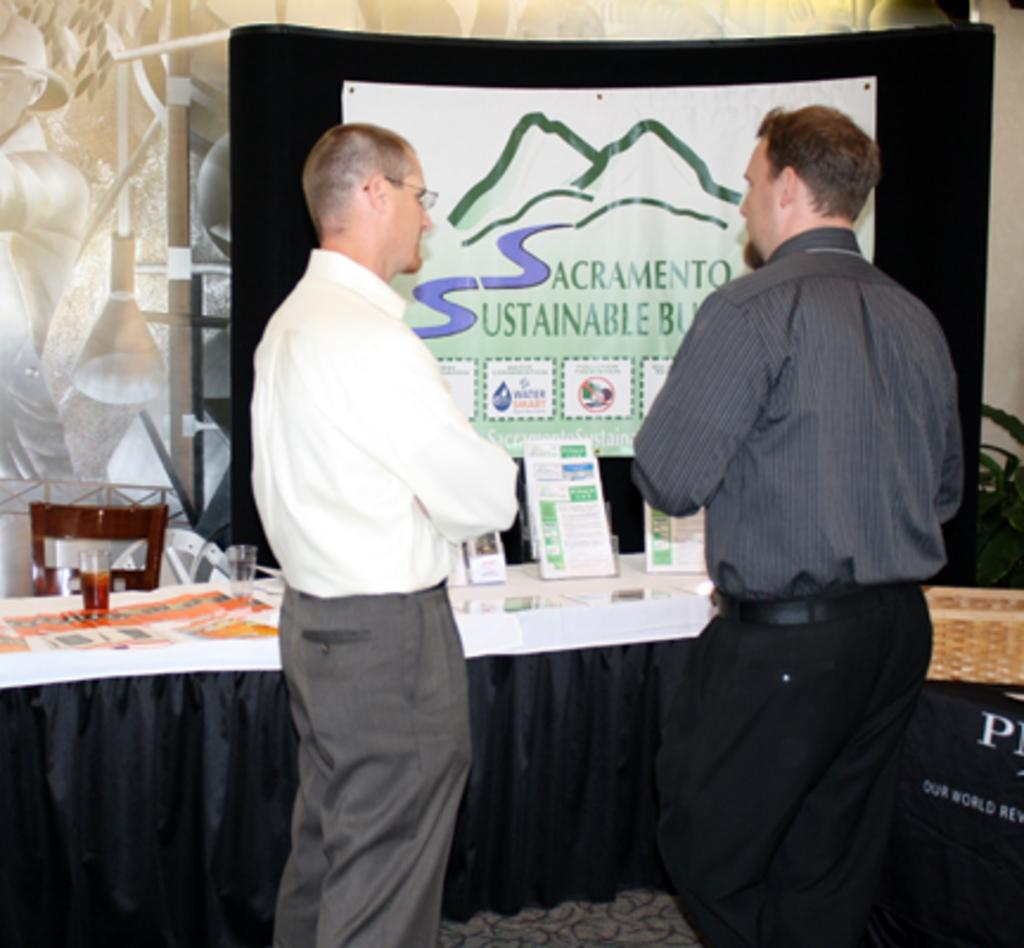How many people are in the image? There are two persons in the image. What are the two persons doing? The two persons are standing and talking. What is located behind the two persons? There is a table behind the two persons. What type of goldfish can be seen swimming in the image? There is no goldfish present in the image; it features two standing persons talking in front of a table. 